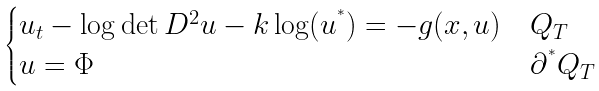<formula> <loc_0><loc_0><loc_500><loc_500>\begin{cases} u _ { t } - \log \det D ^ { 2 } u - k \log ( u ^ { ^ { * } } ) = - g ( x , u ) & Q _ { T } \\ u = \Phi & \partial ^ { ^ { * } } Q _ { T } \end{cases}</formula> 